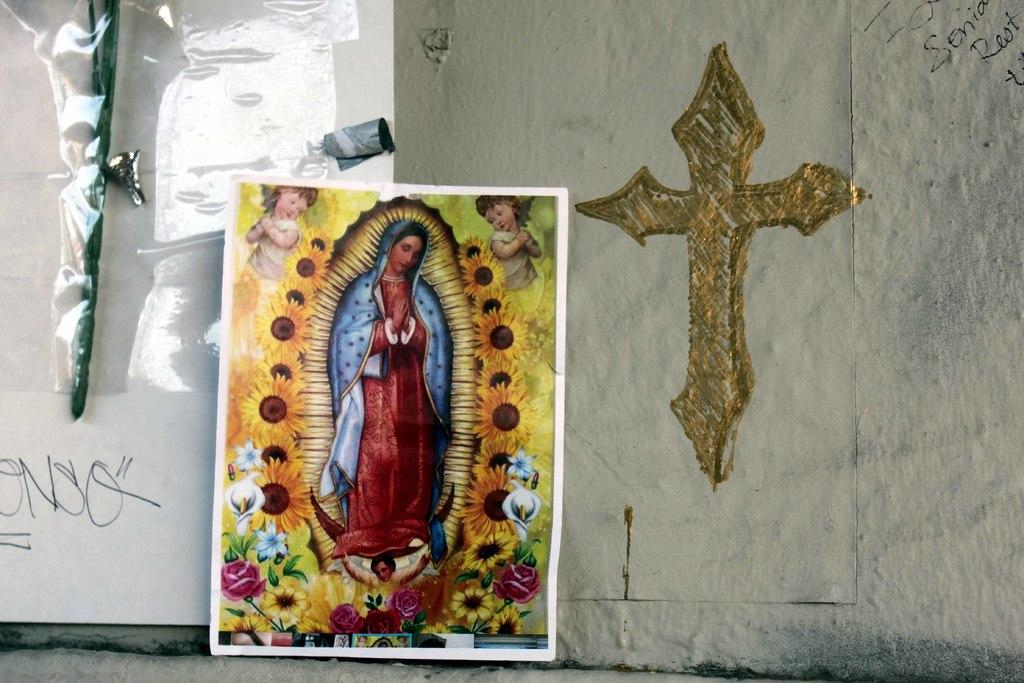<image>
Share a concise interpretation of the image provided. A picture of the Virgin Mary sits against a wall by a cross and some graffiti including the letters Senia. 